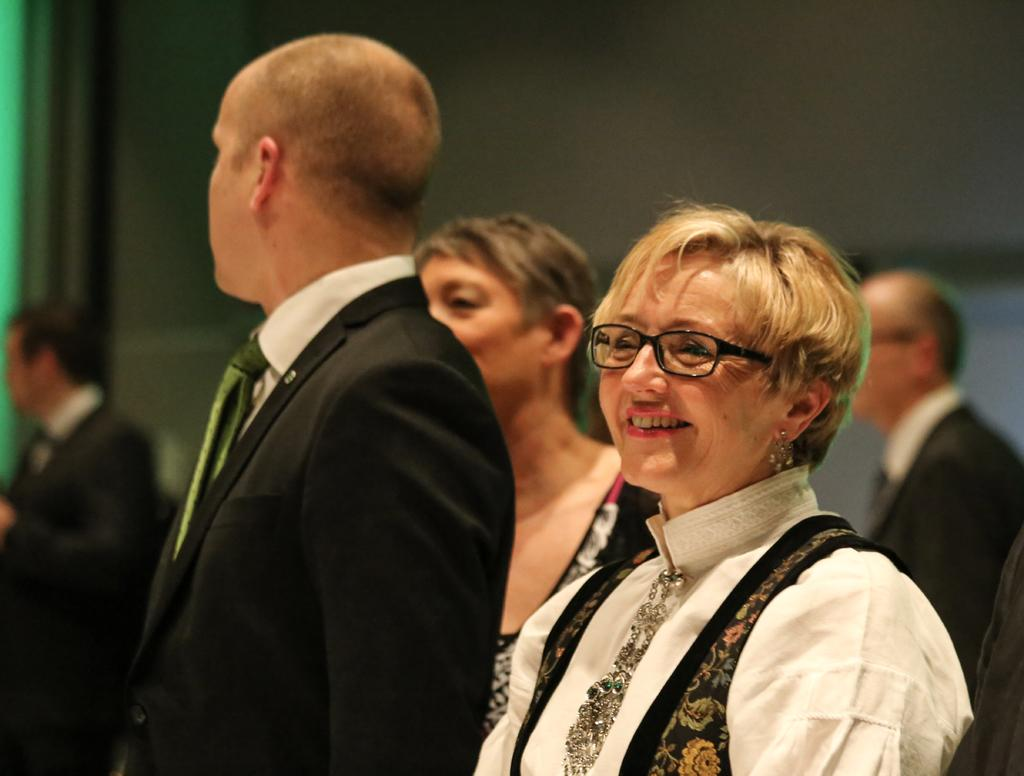Who is present in the image? There is a woman and a man in the image, along with other people. What is the woman wearing? The woman is wearing a white dress. What is the man wearing? The man is wearing a black coat. What is the facial expression of the woman? The woman is smiling. What type of pet can be seen interacting with the man in the image? There is no pet present in the image; it only features the woman, the man, and other people. What type of stamp is visible on the woman's dress in the image? There is no stamp visible on the woman's dress in the image; she is wearing a plain white dress. 